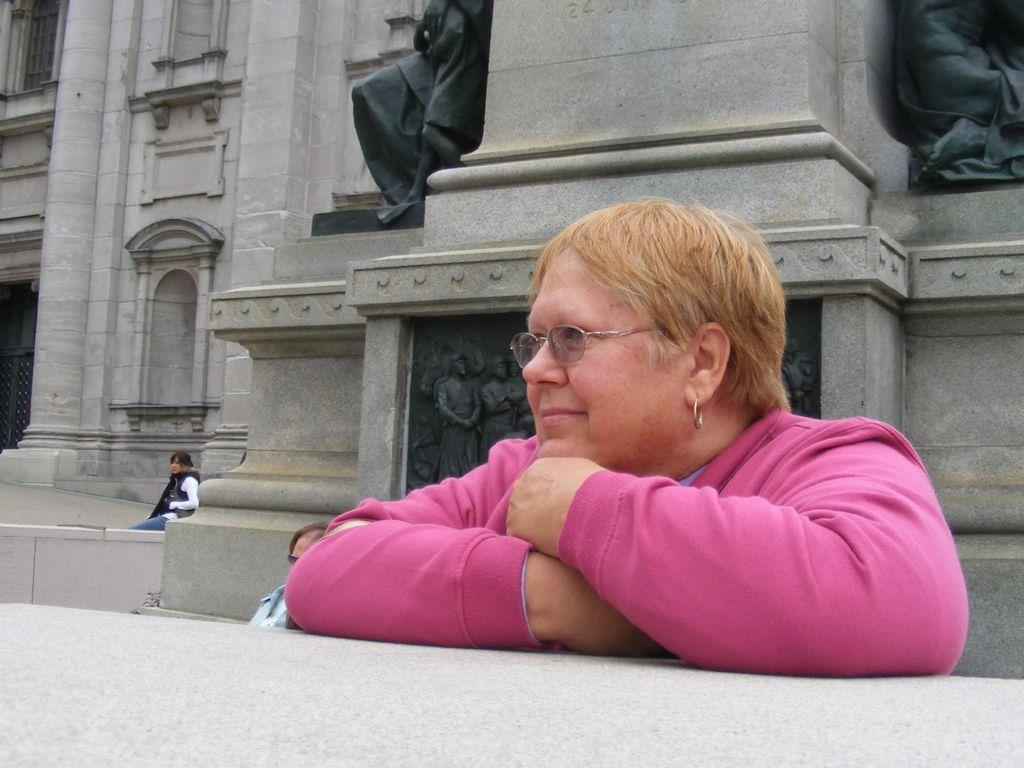Who or what can be seen in the image? There are people in the image. Can you describe any specific features or objects in the image? Yes, there is a statue on a wall in the image. What type of songs are the people singing in the image? There is no indication in the image that the people are singing songs, so it cannot be determined from the picture. 